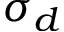<formula> <loc_0><loc_0><loc_500><loc_500>\sigma _ { d }</formula> 